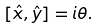Convert formula to latex. <formula><loc_0><loc_0><loc_500><loc_500>[ \hat { x } , \hat { y } ] = i \theta .</formula> 